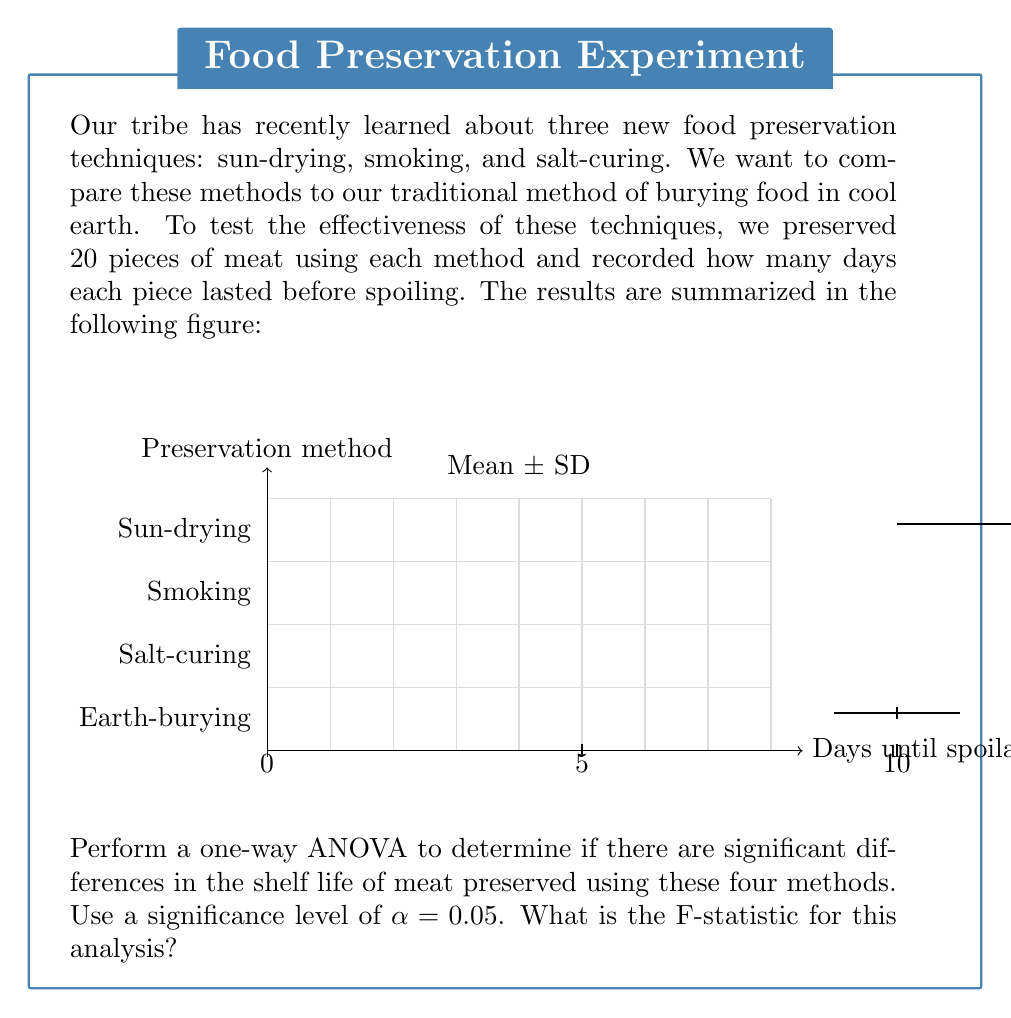Teach me how to tackle this problem. To perform a one-way ANOVA, we need to follow these steps:

1. Calculate the total sum of squares (SST), between-group sum of squares (SSB), and within-group sum of squares (SSW).

2. Calculate the degrees of freedom for between groups (dfB) and within groups (dfW).

3. Calculate the mean square between groups (MSB) and mean square within groups (MSW).

4. Calculate the F-statistic.

Step 1: Calculate sums of squares

SST = $\sum_{i=1}^k \sum_{j=1}^{n_i} (X_{ij} - \bar{X})^2$
SSB = $\sum_{i=1}^k n_i(\bar{X_i} - \bar{X})^2$
SSW = SST - SSB

We don't have individual data points, but we can use the given means and standard deviations to estimate these values.

$\bar{X} = \frac{12 + 15 + 18 + 10}{4} = 13.75$

SSB = $20[(12 - 13.75)^2 + (15 - 13.75)^2 + (18 - 13.75)^2 + (10 - 13.75)^2]$
    = $20[(-1.75)^2 + (1.25)^2 + (4.25)^2 + (-3.75)^2]$
    = $20(3.0625 + 1.5625 + 18.0625 + 14.0625)$
    = $20(36.75)$
    = $735$

SSW = $19[(2^2 + 3^2 + 2^2 + 1^2)]$ (using n-1 for each group)
    = $19(4 + 9 + 4 + 1)$
    = $19(18)$
    = $342$

SST = SSB + SSW = 735 + 342 = 1077

Step 2: Calculate degrees of freedom

dfB = k - 1 = 4 - 1 = 3
dfW = N - k = 80 - 4 = 76
dfT = N - 1 = 80 - 1 = 79

Step 3: Calculate mean squares

MSB = SSB / dfB = 735 / 3 = 245
MSW = SSW / dfW = 342 / 76 = 4.5

Step 4: Calculate F-statistic

F = MSB / MSW = 245 / 4.5 = 54.44
Answer: 54.44 